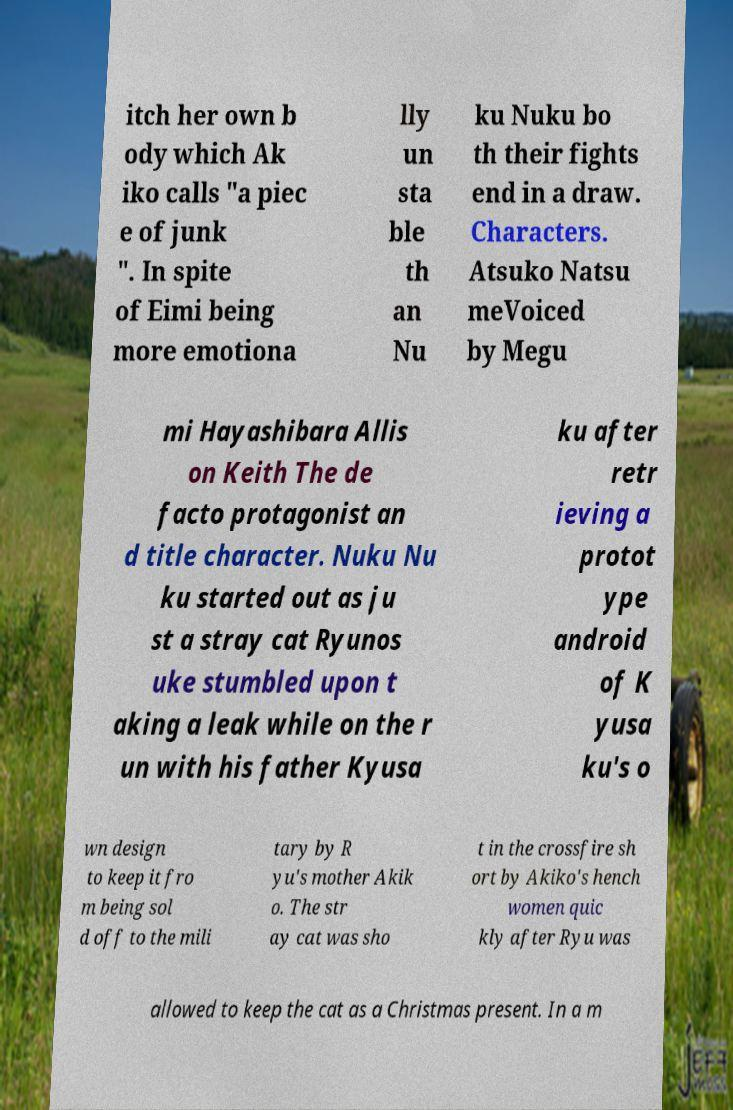Please identify and transcribe the text found in this image. itch her own b ody which Ak iko calls "a piec e of junk ". In spite of Eimi being more emotiona lly un sta ble th an Nu ku Nuku bo th their fights end in a draw. Characters. Atsuko Natsu meVoiced by Megu mi Hayashibara Allis on Keith The de facto protagonist an d title character. Nuku Nu ku started out as ju st a stray cat Ryunos uke stumbled upon t aking a leak while on the r un with his father Kyusa ku after retr ieving a protot ype android of K yusa ku's o wn design to keep it fro m being sol d off to the mili tary by R yu's mother Akik o. The str ay cat was sho t in the crossfire sh ort by Akiko's hench women quic kly after Ryu was allowed to keep the cat as a Christmas present. In a m 